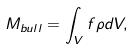Convert formula to latex. <formula><loc_0><loc_0><loc_500><loc_500>M _ { b u l l } = \int _ { V } f \rho d V ,</formula> 